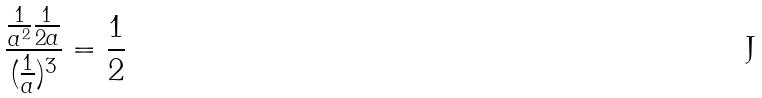<formula> <loc_0><loc_0><loc_500><loc_500>\frac { \frac { 1 } { a ^ { 2 } } \frac { 1 } { 2 a } } { ( \frac { 1 } { a } ) ^ { 3 } } = \frac { 1 } { 2 }</formula> 